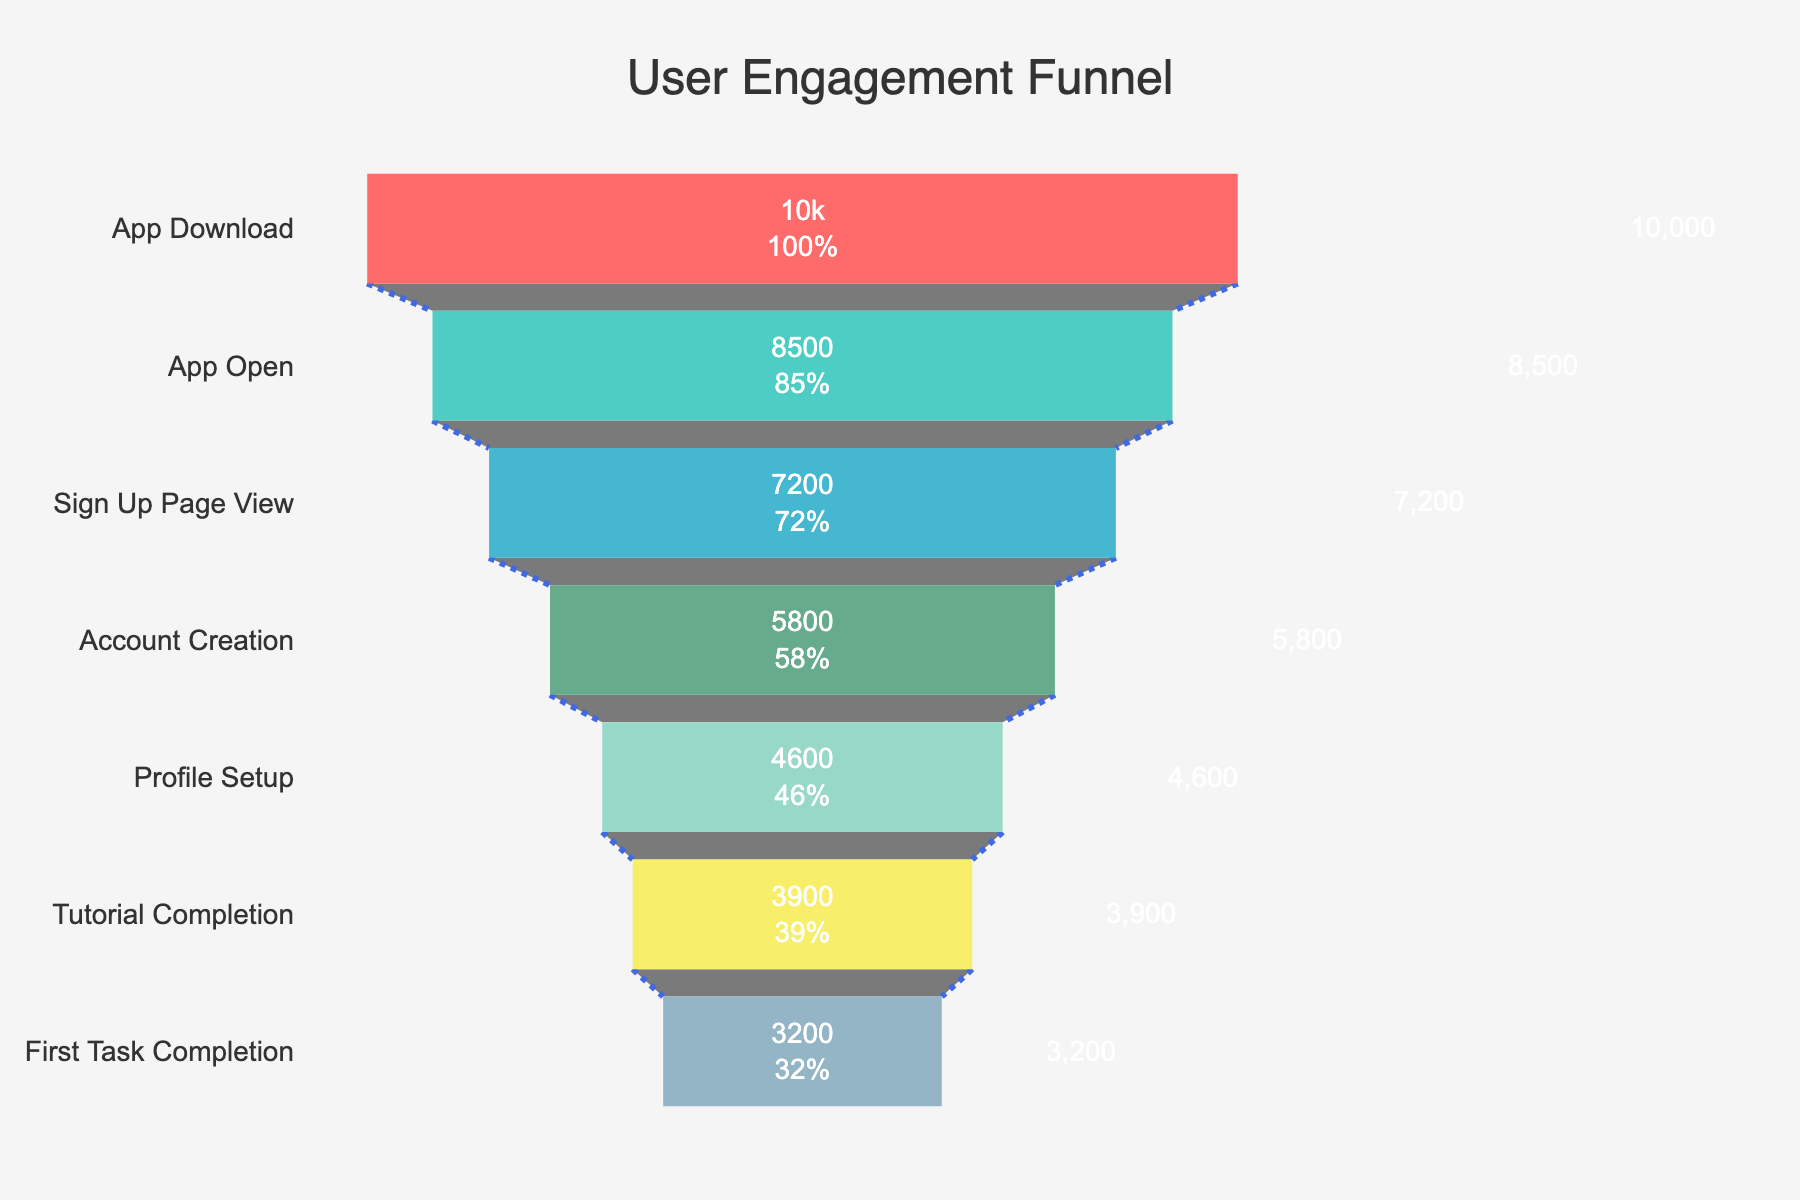What's the title of the funnel chart? The title of the chart is usually displayed at the top and clearly indicates what the chart is about. In this case, it should be visible and easy to identify.
Answer: User Engagement Funnel What is the total number of users who downloaded the app? The funnel chart starts with the highest number of users, which represents the initial stage of user engagement—app downloads.
Answer: 10000 How many users completed the tutorial? Identify the "Tutorial Completion" stage in the chart to determine the number of users who reached this stage in the onboarding process.
Answer: 3900 What is the drop-off rate from the "Account Creation" stage to the "Profile Setup" stage? Compute the difference between the number of users at "Account Creation" (5800) and those at "Profile Setup" (4600), then divide by the number at "Account Creation" and multiply by 100 to get the percentage. (5800-4600)/5800 * 100 = 20.69
Answer: 20.69% Which stage has the highest drop-off rate? Examine the decreases between successive stages to find the largest percentage drop.
Answer: Account Creation to Profile Setup How many users were lost between the "App Open" and "Sign Up Page View" stages? Subtract the number of users at the "Sign Up Page View" stage (7200) from the "App Open" stage (8500).
Answer: 1300 What percentage of users who viewed the "Sign Up Page" went on to create an account? Calculate the ratio of users who created an account (5800) to those who viewed the sign-up page (7200) and multiply by 100 to get the percentage. (5800/7200) * 100 = 80.56
Answer: 80.56% Which two stages have the closest number of users? Compare the number of users at each stage to find the two stages with the smallest difference.
Answer: Profile Setup and Tutorial Completion (4600 vs 3900) How many users completed the first task after completing the tutorial? Compare the numbers for "First Task Completion" and "Tutorial Completion" stages to find the difference.
Answer: 3200 What's the percentage of users who completed the profile setup compared to those who downloaded the app? Calculate the ratio of users who completed the profile setup (4600) to those who downloaded the app (10000) and multiply by 100. (4600/10000) * 100 = 46
Answer: 46% 